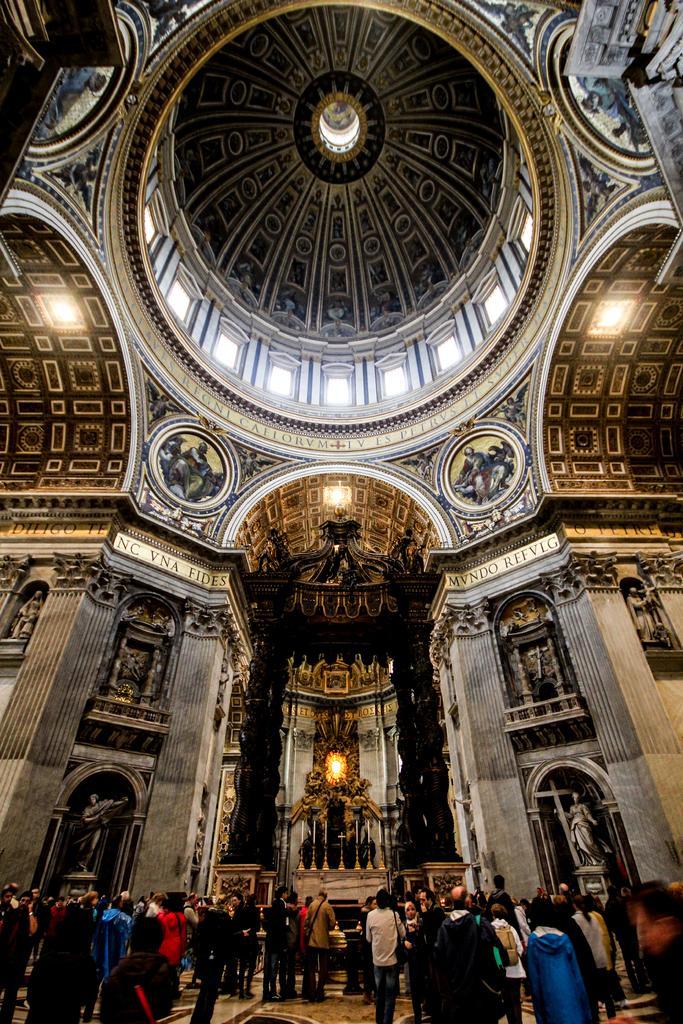Describe this image in one or two sentences. In this picture I can see the inside view of a building. There are group of people standing. I can see lights, sculptures, candles with the candles stands and some other objects. 